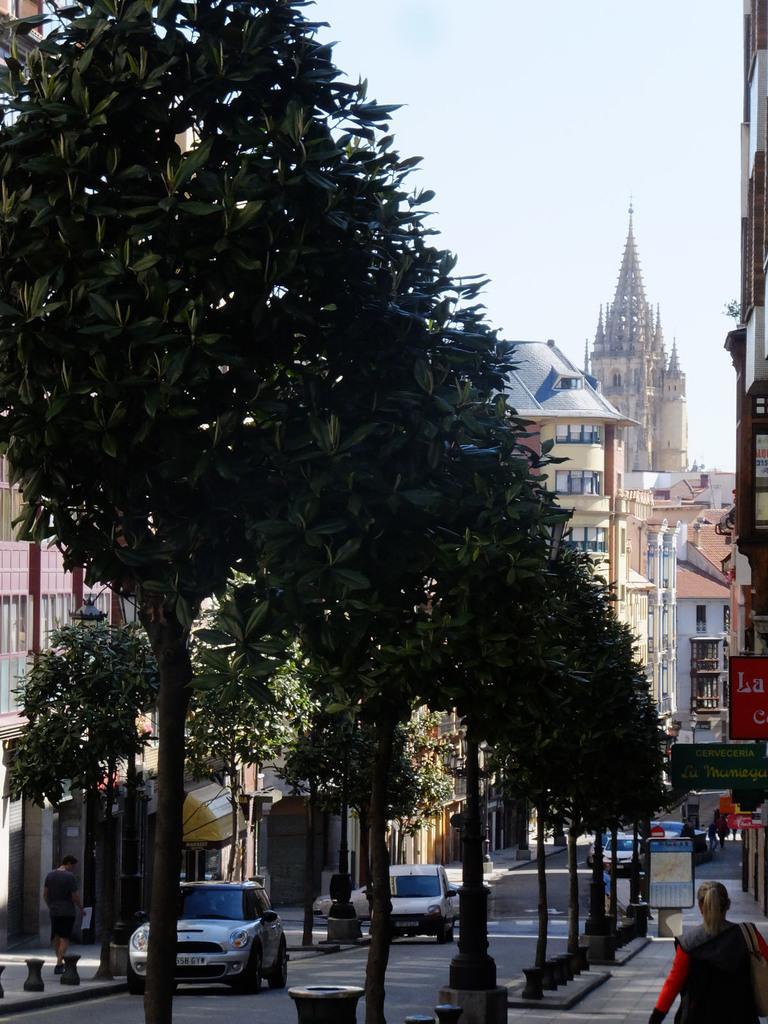Can you describe this image briefly? In this picture there are people, among them one person carrying a bag and we can see trees, boards, light, vehicles on the road, buildings and objects. In the background of the image we can see the sky. 